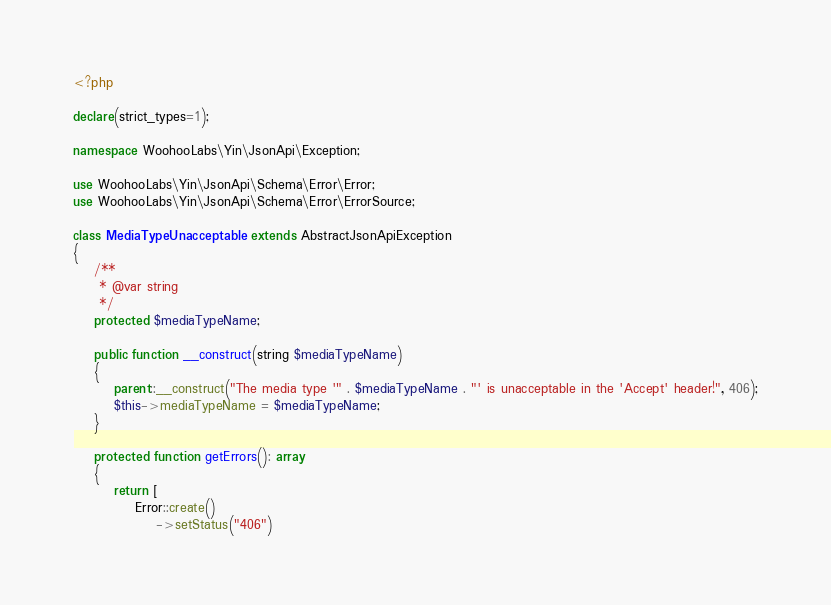<code> <loc_0><loc_0><loc_500><loc_500><_PHP_><?php

declare(strict_types=1);

namespace WoohooLabs\Yin\JsonApi\Exception;

use WoohooLabs\Yin\JsonApi\Schema\Error\Error;
use WoohooLabs\Yin\JsonApi\Schema\Error\ErrorSource;

class MediaTypeUnacceptable extends AbstractJsonApiException
{
    /**
     * @var string
     */
    protected $mediaTypeName;

    public function __construct(string $mediaTypeName)
    {
        parent::__construct("The media type '" . $mediaTypeName . "' is unacceptable in the 'Accept' header!", 406);
        $this->mediaTypeName = $mediaTypeName;
    }

    protected function getErrors(): array
    {
        return [
            Error::create()
                ->setStatus("406")</code> 